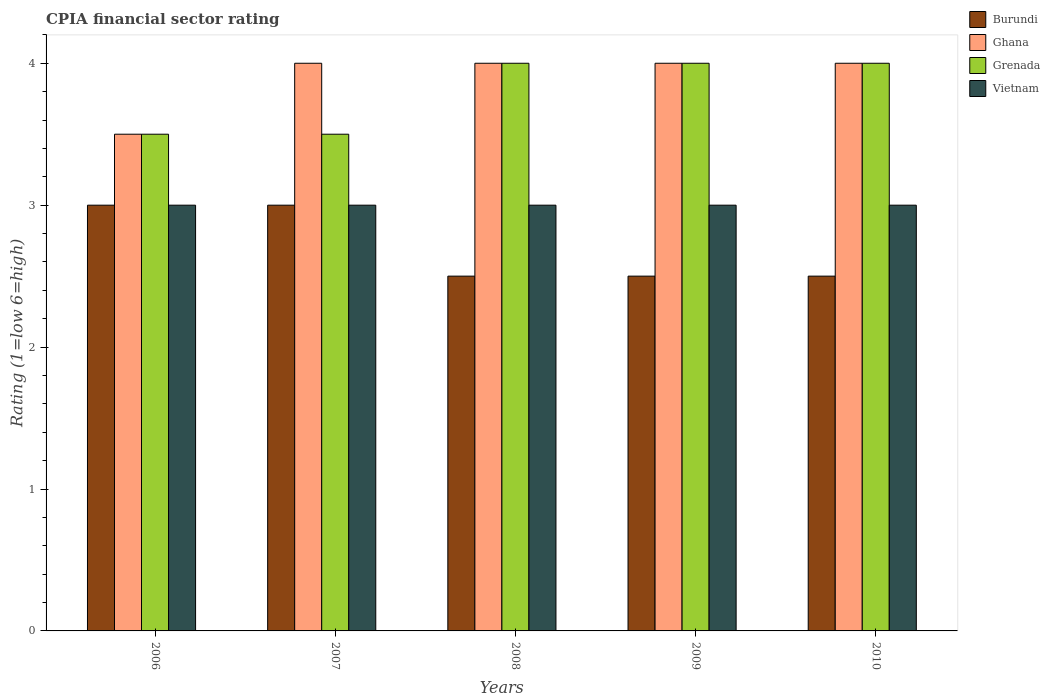How many different coloured bars are there?
Offer a very short reply. 4. Are the number of bars on each tick of the X-axis equal?
Offer a terse response. Yes. How many bars are there on the 5th tick from the left?
Give a very brief answer. 4. Across all years, what is the minimum CPIA rating in Ghana?
Give a very brief answer. 3.5. In which year was the CPIA rating in Burundi minimum?
Offer a terse response. 2008. What is the total CPIA rating in Ghana in the graph?
Offer a terse response. 19.5. What is the difference between the CPIA rating in Ghana in 2006 and that in 2010?
Make the answer very short. -0.5. In how many years, is the CPIA rating in Ghana greater than 1.8?
Provide a short and direct response. 5. Is the difference between the CPIA rating in Burundi in 2009 and 2010 greater than the difference between the CPIA rating in Grenada in 2009 and 2010?
Provide a short and direct response. No. What is the difference between the highest and the second highest CPIA rating in Vietnam?
Make the answer very short. 0. What is the difference between the highest and the lowest CPIA rating in Burundi?
Provide a short and direct response. 0.5. What does the 2nd bar from the right in 2010 represents?
Your response must be concise. Grenada. Is it the case that in every year, the sum of the CPIA rating in Burundi and CPIA rating in Grenada is greater than the CPIA rating in Ghana?
Keep it short and to the point. Yes. How many bars are there?
Offer a very short reply. 20. What is the difference between two consecutive major ticks on the Y-axis?
Provide a succinct answer. 1. Does the graph contain any zero values?
Ensure brevity in your answer.  No. How many legend labels are there?
Your answer should be compact. 4. How are the legend labels stacked?
Offer a very short reply. Vertical. What is the title of the graph?
Ensure brevity in your answer.  CPIA financial sector rating. What is the label or title of the Y-axis?
Ensure brevity in your answer.  Rating (1=low 6=high). What is the Rating (1=low 6=high) in Burundi in 2006?
Make the answer very short. 3. What is the Rating (1=low 6=high) of Vietnam in 2006?
Provide a short and direct response. 3. What is the Rating (1=low 6=high) in Burundi in 2007?
Offer a very short reply. 3. What is the Rating (1=low 6=high) of Burundi in 2008?
Your response must be concise. 2.5. What is the Rating (1=low 6=high) of Ghana in 2008?
Your answer should be very brief. 4. What is the Rating (1=low 6=high) in Grenada in 2008?
Offer a terse response. 4. What is the Rating (1=low 6=high) in Vietnam in 2008?
Give a very brief answer. 3. What is the Rating (1=low 6=high) in Burundi in 2009?
Provide a short and direct response. 2.5. What is the Rating (1=low 6=high) in Ghana in 2009?
Provide a short and direct response. 4. What is the Rating (1=low 6=high) in Grenada in 2009?
Provide a short and direct response. 4. What is the Rating (1=low 6=high) of Burundi in 2010?
Your response must be concise. 2.5. What is the Rating (1=low 6=high) of Grenada in 2010?
Your answer should be very brief. 4. Across all years, what is the maximum Rating (1=low 6=high) of Ghana?
Your answer should be very brief. 4. Across all years, what is the maximum Rating (1=low 6=high) in Grenada?
Offer a terse response. 4. Across all years, what is the maximum Rating (1=low 6=high) in Vietnam?
Keep it short and to the point. 3. What is the difference between the Rating (1=low 6=high) in Burundi in 2006 and that in 2007?
Provide a succinct answer. 0. What is the difference between the Rating (1=low 6=high) of Ghana in 2006 and that in 2007?
Offer a terse response. -0.5. What is the difference between the Rating (1=low 6=high) of Grenada in 2006 and that in 2007?
Offer a terse response. 0. What is the difference between the Rating (1=low 6=high) in Vietnam in 2006 and that in 2007?
Ensure brevity in your answer.  0. What is the difference between the Rating (1=low 6=high) in Ghana in 2006 and that in 2009?
Give a very brief answer. -0.5. What is the difference between the Rating (1=low 6=high) in Vietnam in 2006 and that in 2009?
Give a very brief answer. 0. What is the difference between the Rating (1=low 6=high) of Grenada in 2007 and that in 2008?
Provide a succinct answer. -0.5. What is the difference between the Rating (1=low 6=high) of Grenada in 2007 and that in 2009?
Your answer should be compact. -0.5. What is the difference between the Rating (1=low 6=high) in Burundi in 2007 and that in 2010?
Make the answer very short. 0.5. What is the difference between the Rating (1=low 6=high) of Ghana in 2007 and that in 2010?
Your response must be concise. 0. What is the difference between the Rating (1=low 6=high) in Burundi in 2008 and that in 2009?
Offer a very short reply. 0. What is the difference between the Rating (1=low 6=high) in Grenada in 2008 and that in 2009?
Your answer should be compact. 0. What is the difference between the Rating (1=low 6=high) of Burundi in 2008 and that in 2010?
Make the answer very short. 0. What is the difference between the Rating (1=low 6=high) in Grenada in 2008 and that in 2010?
Ensure brevity in your answer.  0. What is the difference between the Rating (1=low 6=high) in Vietnam in 2008 and that in 2010?
Make the answer very short. 0. What is the difference between the Rating (1=low 6=high) of Burundi in 2009 and that in 2010?
Offer a terse response. 0. What is the difference between the Rating (1=low 6=high) in Vietnam in 2009 and that in 2010?
Provide a succinct answer. 0. What is the difference between the Rating (1=low 6=high) in Burundi in 2006 and the Rating (1=low 6=high) in Ghana in 2007?
Your answer should be very brief. -1. What is the difference between the Rating (1=low 6=high) of Grenada in 2006 and the Rating (1=low 6=high) of Vietnam in 2007?
Your answer should be very brief. 0.5. What is the difference between the Rating (1=low 6=high) in Burundi in 2006 and the Rating (1=low 6=high) in Ghana in 2008?
Your response must be concise. -1. What is the difference between the Rating (1=low 6=high) of Burundi in 2006 and the Rating (1=low 6=high) of Ghana in 2009?
Offer a terse response. -1. What is the difference between the Rating (1=low 6=high) of Burundi in 2006 and the Rating (1=low 6=high) of Grenada in 2009?
Offer a very short reply. -1. What is the difference between the Rating (1=low 6=high) in Ghana in 2006 and the Rating (1=low 6=high) in Grenada in 2010?
Provide a succinct answer. -0.5. What is the difference between the Rating (1=low 6=high) of Grenada in 2006 and the Rating (1=low 6=high) of Vietnam in 2010?
Offer a very short reply. 0.5. What is the difference between the Rating (1=low 6=high) in Burundi in 2007 and the Rating (1=low 6=high) in Ghana in 2008?
Your answer should be very brief. -1. What is the difference between the Rating (1=low 6=high) in Burundi in 2007 and the Rating (1=low 6=high) in Vietnam in 2008?
Make the answer very short. 0. What is the difference between the Rating (1=low 6=high) in Ghana in 2007 and the Rating (1=low 6=high) in Grenada in 2008?
Provide a short and direct response. 0. What is the difference between the Rating (1=low 6=high) in Grenada in 2007 and the Rating (1=low 6=high) in Vietnam in 2008?
Your response must be concise. 0.5. What is the difference between the Rating (1=low 6=high) of Burundi in 2007 and the Rating (1=low 6=high) of Ghana in 2009?
Keep it short and to the point. -1. What is the difference between the Rating (1=low 6=high) of Burundi in 2007 and the Rating (1=low 6=high) of Vietnam in 2009?
Provide a short and direct response. 0. What is the difference between the Rating (1=low 6=high) of Ghana in 2007 and the Rating (1=low 6=high) of Grenada in 2009?
Keep it short and to the point. 0. What is the difference between the Rating (1=low 6=high) of Ghana in 2007 and the Rating (1=low 6=high) of Vietnam in 2009?
Offer a terse response. 1. What is the difference between the Rating (1=low 6=high) in Burundi in 2007 and the Rating (1=low 6=high) in Ghana in 2010?
Give a very brief answer. -1. What is the difference between the Rating (1=low 6=high) of Burundi in 2007 and the Rating (1=low 6=high) of Vietnam in 2010?
Keep it short and to the point. 0. What is the difference between the Rating (1=low 6=high) in Ghana in 2007 and the Rating (1=low 6=high) in Vietnam in 2010?
Your response must be concise. 1. What is the difference between the Rating (1=low 6=high) in Grenada in 2007 and the Rating (1=low 6=high) in Vietnam in 2010?
Provide a succinct answer. 0.5. What is the difference between the Rating (1=low 6=high) in Burundi in 2008 and the Rating (1=low 6=high) in Grenada in 2009?
Your response must be concise. -1.5. What is the difference between the Rating (1=low 6=high) of Burundi in 2008 and the Rating (1=low 6=high) of Vietnam in 2009?
Offer a terse response. -0.5. What is the difference between the Rating (1=low 6=high) in Grenada in 2008 and the Rating (1=low 6=high) in Vietnam in 2009?
Make the answer very short. 1. What is the difference between the Rating (1=low 6=high) in Burundi in 2008 and the Rating (1=low 6=high) in Ghana in 2010?
Give a very brief answer. -1.5. What is the difference between the Rating (1=low 6=high) of Burundi in 2008 and the Rating (1=low 6=high) of Grenada in 2010?
Offer a terse response. -1.5. What is the difference between the Rating (1=low 6=high) in Burundi in 2008 and the Rating (1=low 6=high) in Vietnam in 2010?
Your answer should be very brief. -0.5. What is the difference between the Rating (1=low 6=high) of Ghana in 2008 and the Rating (1=low 6=high) of Grenada in 2010?
Give a very brief answer. 0. What is the difference between the Rating (1=low 6=high) in Burundi in 2009 and the Rating (1=low 6=high) in Grenada in 2010?
Offer a terse response. -1.5. What is the difference between the Rating (1=low 6=high) in Burundi in 2009 and the Rating (1=low 6=high) in Vietnam in 2010?
Provide a succinct answer. -0.5. What is the difference between the Rating (1=low 6=high) of Ghana in 2009 and the Rating (1=low 6=high) of Grenada in 2010?
Offer a very short reply. 0. What is the difference between the Rating (1=low 6=high) in Grenada in 2009 and the Rating (1=low 6=high) in Vietnam in 2010?
Provide a succinct answer. 1. What is the average Rating (1=low 6=high) of Burundi per year?
Your response must be concise. 2.7. What is the average Rating (1=low 6=high) of Ghana per year?
Provide a short and direct response. 3.9. What is the average Rating (1=low 6=high) of Vietnam per year?
Your response must be concise. 3. In the year 2006, what is the difference between the Rating (1=low 6=high) in Ghana and Rating (1=low 6=high) in Grenada?
Make the answer very short. 0. In the year 2006, what is the difference between the Rating (1=low 6=high) of Ghana and Rating (1=low 6=high) of Vietnam?
Ensure brevity in your answer.  0.5. In the year 2007, what is the difference between the Rating (1=low 6=high) of Burundi and Rating (1=low 6=high) of Ghana?
Give a very brief answer. -1. In the year 2008, what is the difference between the Rating (1=low 6=high) in Burundi and Rating (1=low 6=high) in Grenada?
Your answer should be compact. -1.5. In the year 2008, what is the difference between the Rating (1=low 6=high) in Ghana and Rating (1=low 6=high) in Grenada?
Give a very brief answer. 0. In the year 2008, what is the difference between the Rating (1=low 6=high) of Ghana and Rating (1=low 6=high) of Vietnam?
Ensure brevity in your answer.  1. In the year 2008, what is the difference between the Rating (1=low 6=high) in Grenada and Rating (1=low 6=high) in Vietnam?
Offer a terse response. 1. In the year 2009, what is the difference between the Rating (1=low 6=high) of Burundi and Rating (1=low 6=high) of Ghana?
Make the answer very short. -1.5. In the year 2009, what is the difference between the Rating (1=low 6=high) of Burundi and Rating (1=low 6=high) of Vietnam?
Provide a short and direct response. -0.5. In the year 2009, what is the difference between the Rating (1=low 6=high) of Ghana and Rating (1=low 6=high) of Grenada?
Keep it short and to the point. 0. In the year 2009, what is the difference between the Rating (1=low 6=high) in Ghana and Rating (1=low 6=high) in Vietnam?
Ensure brevity in your answer.  1. In the year 2009, what is the difference between the Rating (1=low 6=high) in Grenada and Rating (1=low 6=high) in Vietnam?
Your answer should be very brief. 1. In the year 2010, what is the difference between the Rating (1=low 6=high) in Burundi and Rating (1=low 6=high) in Ghana?
Make the answer very short. -1.5. In the year 2010, what is the difference between the Rating (1=low 6=high) in Burundi and Rating (1=low 6=high) in Vietnam?
Provide a succinct answer. -0.5. In the year 2010, what is the difference between the Rating (1=low 6=high) in Ghana and Rating (1=low 6=high) in Grenada?
Give a very brief answer. 0. In the year 2010, what is the difference between the Rating (1=low 6=high) in Grenada and Rating (1=low 6=high) in Vietnam?
Your answer should be very brief. 1. What is the ratio of the Rating (1=low 6=high) of Grenada in 2006 to that in 2007?
Provide a succinct answer. 1. What is the ratio of the Rating (1=low 6=high) in Vietnam in 2006 to that in 2007?
Make the answer very short. 1. What is the ratio of the Rating (1=low 6=high) in Ghana in 2006 to that in 2008?
Offer a very short reply. 0.88. What is the ratio of the Rating (1=low 6=high) in Grenada in 2006 to that in 2009?
Offer a terse response. 0.88. What is the ratio of the Rating (1=low 6=high) in Vietnam in 2006 to that in 2010?
Your answer should be compact. 1. What is the ratio of the Rating (1=low 6=high) in Ghana in 2007 to that in 2008?
Give a very brief answer. 1. What is the ratio of the Rating (1=low 6=high) in Grenada in 2007 to that in 2008?
Ensure brevity in your answer.  0.88. What is the ratio of the Rating (1=low 6=high) of Ghana in 2007 to that in 2009?
Your response must be concise. 1. What is the ratio of the Rating (1=low 6=high) of Grenada in 2007 to that in 2009?
Offer a very short reply. 0.88. What is the ratio of the Rating (1=low 6=high) in Vietnam in 2007 to that in 2009?
Keep it short and to the point. 1. What is the ratio of the Rating (1=low 6=high) in Ghana in 2007 to that in 2010?
Give a very brief answer. 1. What is the ratio of the Rating (1=low 6=high) in Grenada in 2007 to that in 2010?
Provide a succinct answer. 0.88. What is the ratio of the Rating (1=low 6=high) in Vietnam in 2008 to that in 2009?
Provide a succinct answer. 1. What is the ratio of the Rating (1=low 6=high) in Grenada in 2008 to that in 2010?
Make the answer very short. 1. What is the ratio of the Rating (1=low 6=high) of Vietnam in 2008 to that in 2010?
Ensure brevity in your answer.  1. What is the ratio of the Rating (1=low 6=high) in Grenada in 2009 to that in 2010?
Offer a very short reply. 1. What is the ratio of the Rating (1=low 6=high) in Vietnam in 2009 to that in 2010?
Make the answer very short. 1. What is the difference between the highest and the lowest Rating (1=low 6=high) in Grenada?
Offer a very short reply. 0.5. 